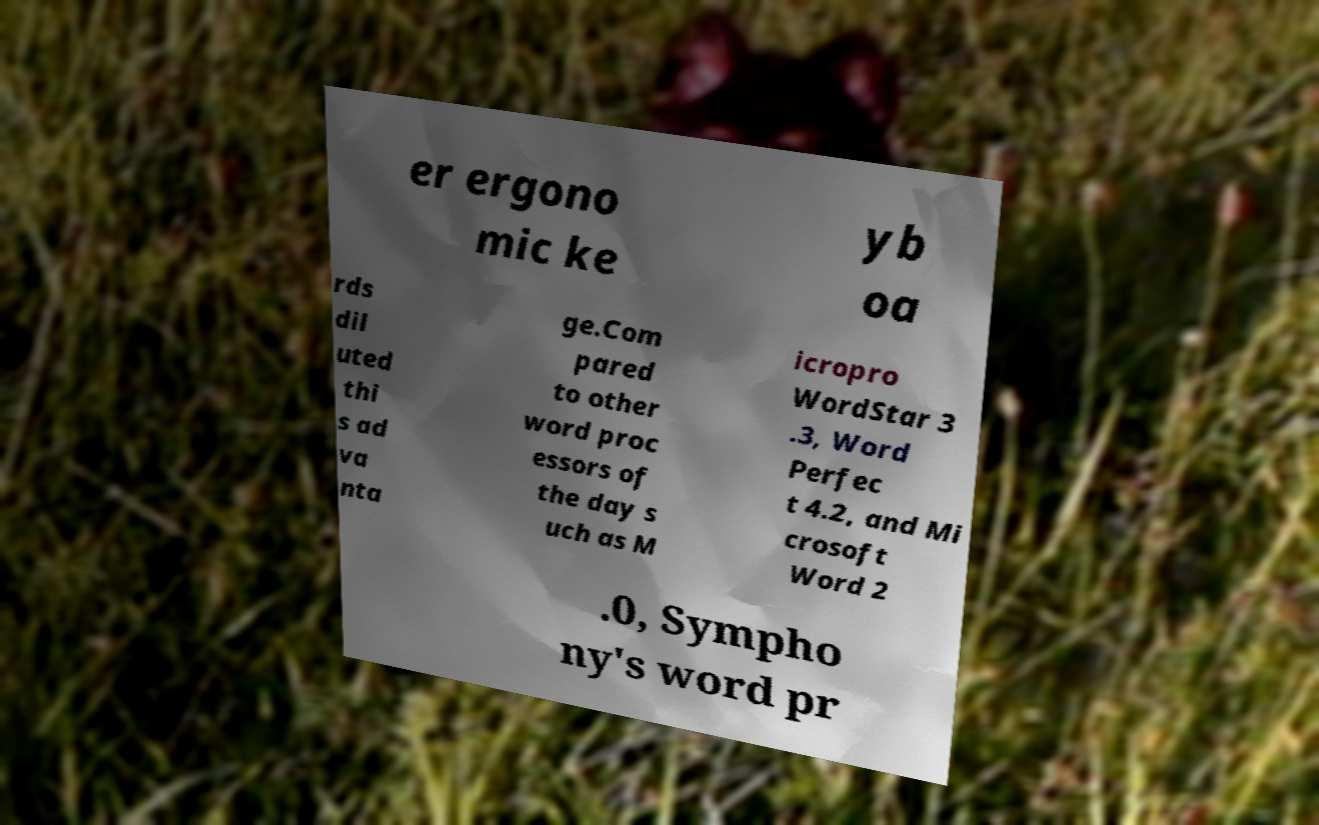Please read and relay the text visible in this image. What does it say? er ergono mic ke yb oa rds dil uted thi s ad va nta ge.Com pared to other word proc essors of the day s uch as M icropro WordStar 3 .3, Word Perfec t 4.2, and Mi crosoft Word 2 .0, Sympho ny's word pr 